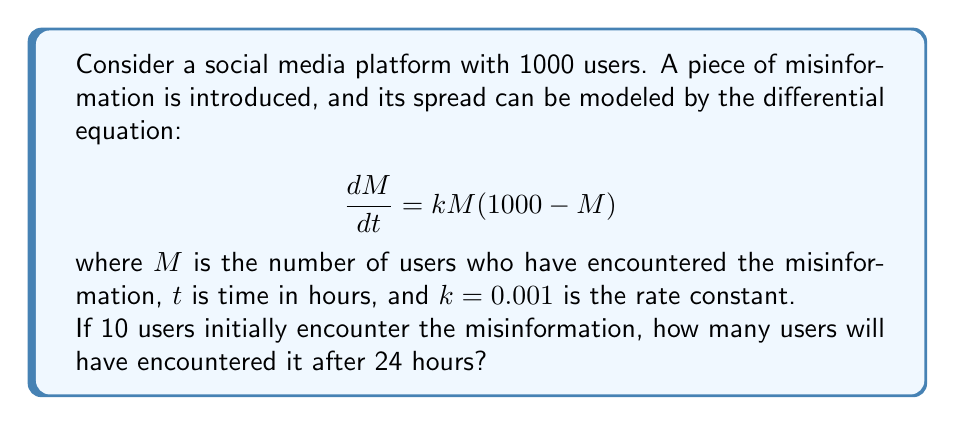Solve this math problem. This problem uses a logistic growth model to represent the spread of misinformation. Let's break it down step-by-step:

1. The differential equation is in the form of logistic growth:
   $$\frac{dM}{dt} = kM(N - M)$$
   where $N = 1000$ is the total population.

2. The solution to this equation is:
   $$M(t) = \frac{N}{1 + Ce^{-kNt}}$$
   where $C$ is a constant determined by the initial condition.

3. We're given that $M(0) = 10$, so we can find $C$:
   $$10 = \frac{1000}{1 + C}$$
   $$C = 99$$

4. Now we have the full solution:
   $$M(t) = \frac{1000}{1 + 99e^{-t}}$$
   where we've simplified $kN = 0.001 * 1000 = 1$.

5. To find $M(24)$, we plug in $t = 24$:
   $$M(24) = \frac{1000}{1 + 99e^{-24}}$$

6. Using a calculator or computer:
   $$M(24) \approx 999.9999$$

7. Since we're dealing with people, we round down to the nearest whole number.
Answer: After 24 hours, 999 users will have encountered the misinformation. 